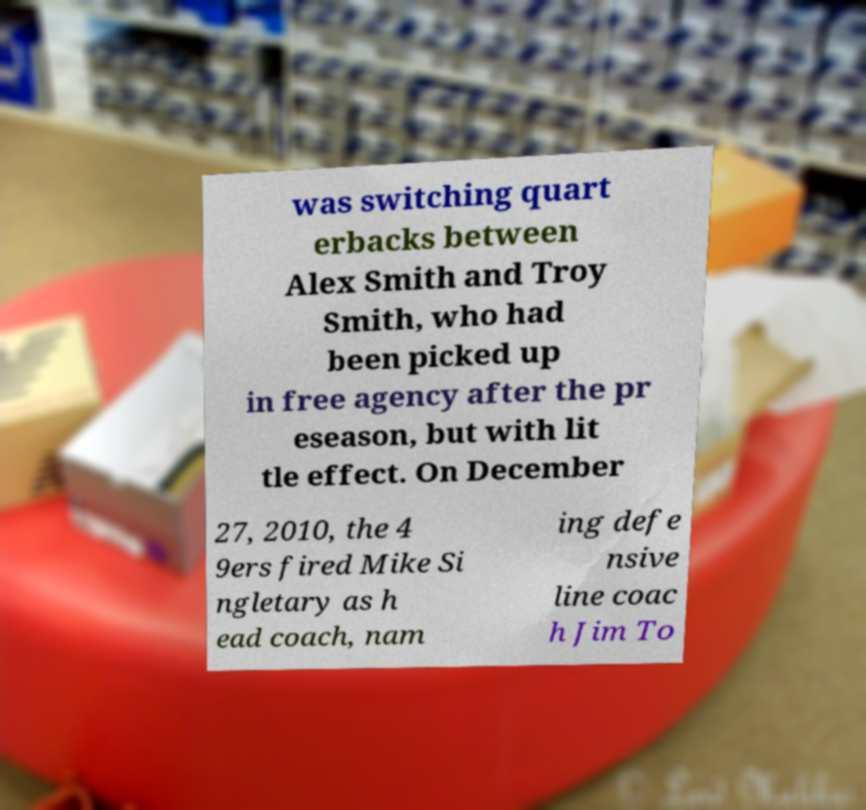For documentation purposes, I need the text within this image transcribed. Could you provide that? was switching quart erbacks between Alex Smith and Troy Smith, who had been picked up in free agency after the pr eseason, but with lit tle effect. On December 27, 2010, the 4 9ers fired Mike Si ngletary as h ead coach, nam ing defe nsive line coac h Jim To 